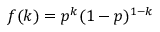Convert formula to latex. <formula><loc_0><loc_0><loc_500><loc_500>f ( k ) = p ^ { k } ( 1 - p ) ^ { 1 - k }</formula> 